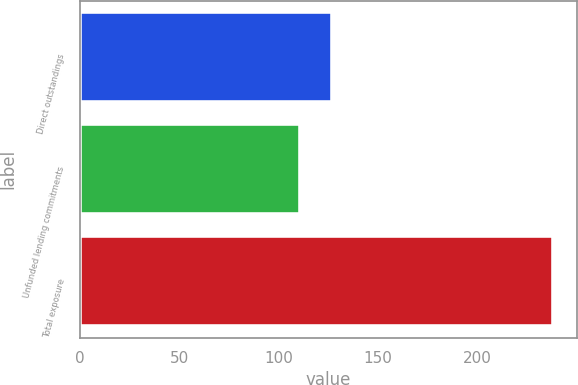Convert chart to OTSL. <chart><loc_0><loc_0><loc_500><loc_500><bar_chart><fcel>Direct outstandings<fcel>Unfunded lending commitments<fcel>Total exposure<nl><fcel>127<fcel>111<fcel>238<nl></chart> 